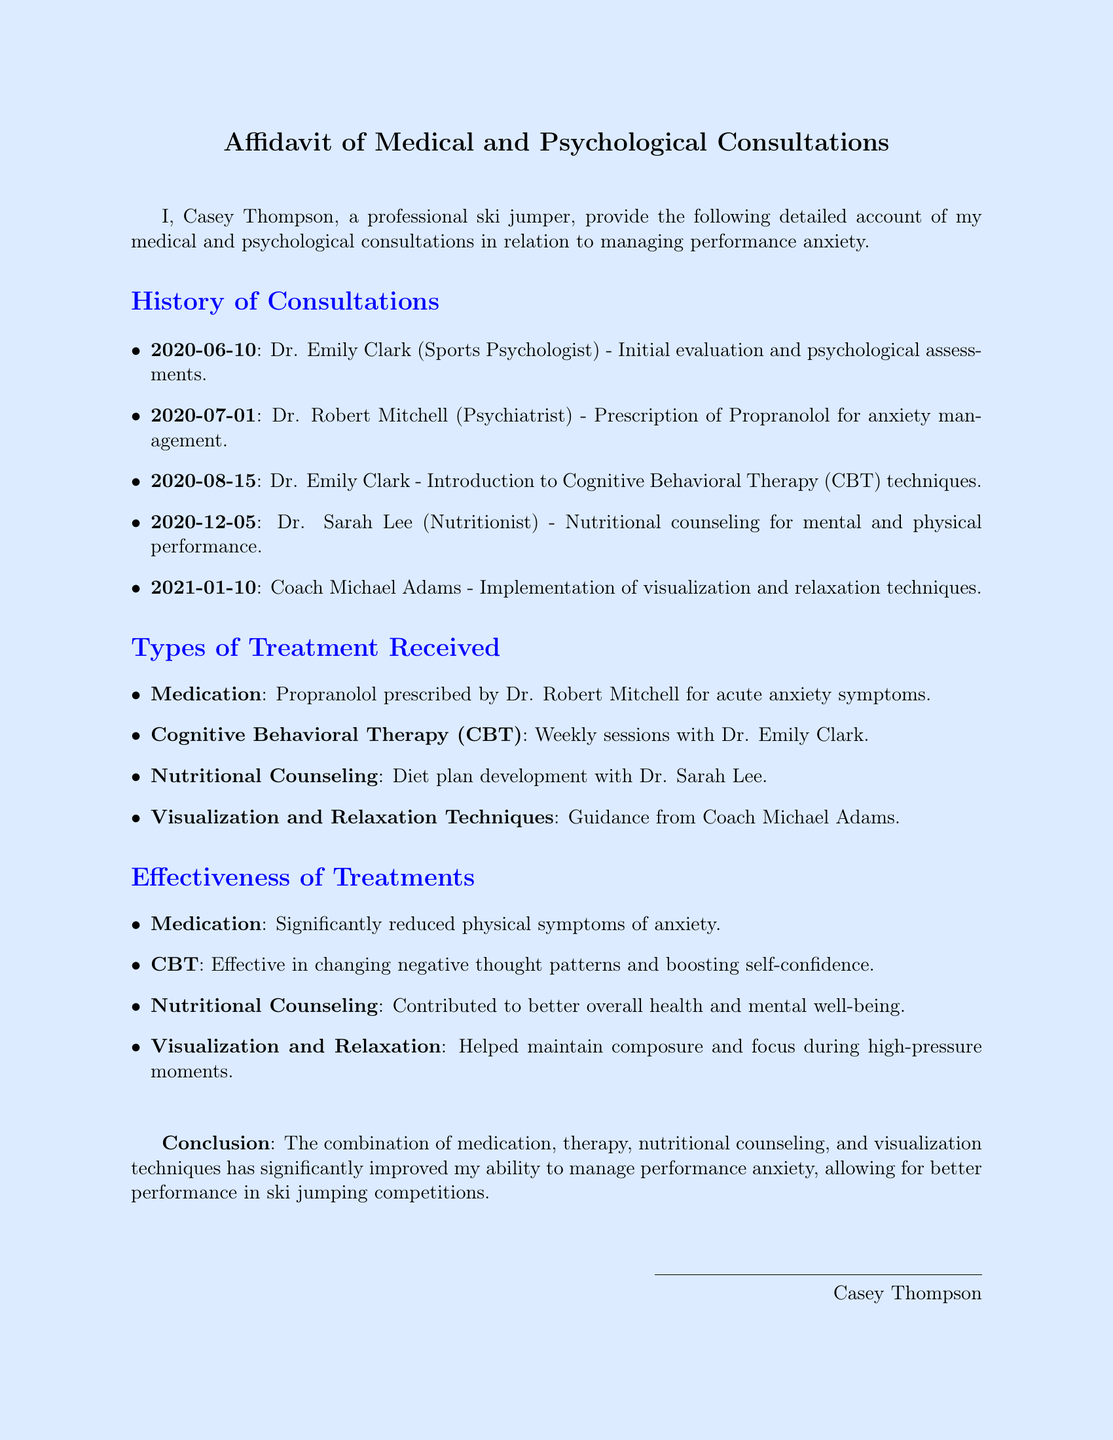What is the name of the sports psychologist? The document states that the sports psychologist's name is Dr. Emily Clark.
Answer: Dr. Emily Clark When did the first evaluation take place? The initial evaluation was conducted on June 10, 2020.
Answer: 2020-06-10 What medication was prescribed for anxiety management? The medication prescribed to manage anxiety is Propranolol.
Answer: Propranolol Which therapy technique was introduced on August 15, 2020? On August 15, 2020, Cognitive Behavioral Therapy (CBT) techniques were introduced.
Answer: Cognitive Behavioral Therapy (CBT) What impact did the medication have on anxiety symptoms? The document mentions that the medication significantly reduced physical symptoms of anxiety.
Answer: Significantly reduced physical symptoms How did nutritional counseling contribute to Casey's mental well-being? Nutritional counseling contributed to better overall health and mental well-being.
Answer: Better overall health and mental well-being What advice did Coach Michael Adams provide? Coach Michael Adams provided guidance on visualization and relaxation techniques.
Answer: Visualization and relaxation techniques What is the conclusion regarding the combination of treatments? The conclusion states that the combination of treatments significantly improved the ability to manage performance anxiety.
Answer: Significantly improved ability to manage performance anxiety 